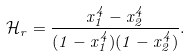Convert formula to latex. <formula><loc_0><loc_0><loc_500><loc_500>\mathcal { H } _ { r } = \frac { x _ { 1 } ^ { 4 } - x _ { 2 } ^ { 4 } } { ( 1 - x _ { 1 } ^ { 4 } ) ( 1 - x _ { 2 } ^ { 4 } ) } .</formula> 